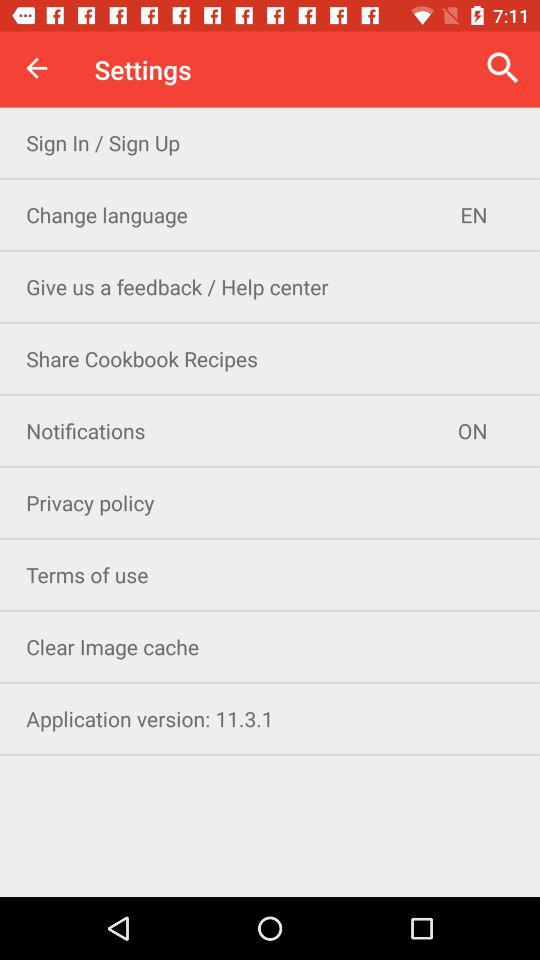What is the version of the application? The version is 11.3.1. 